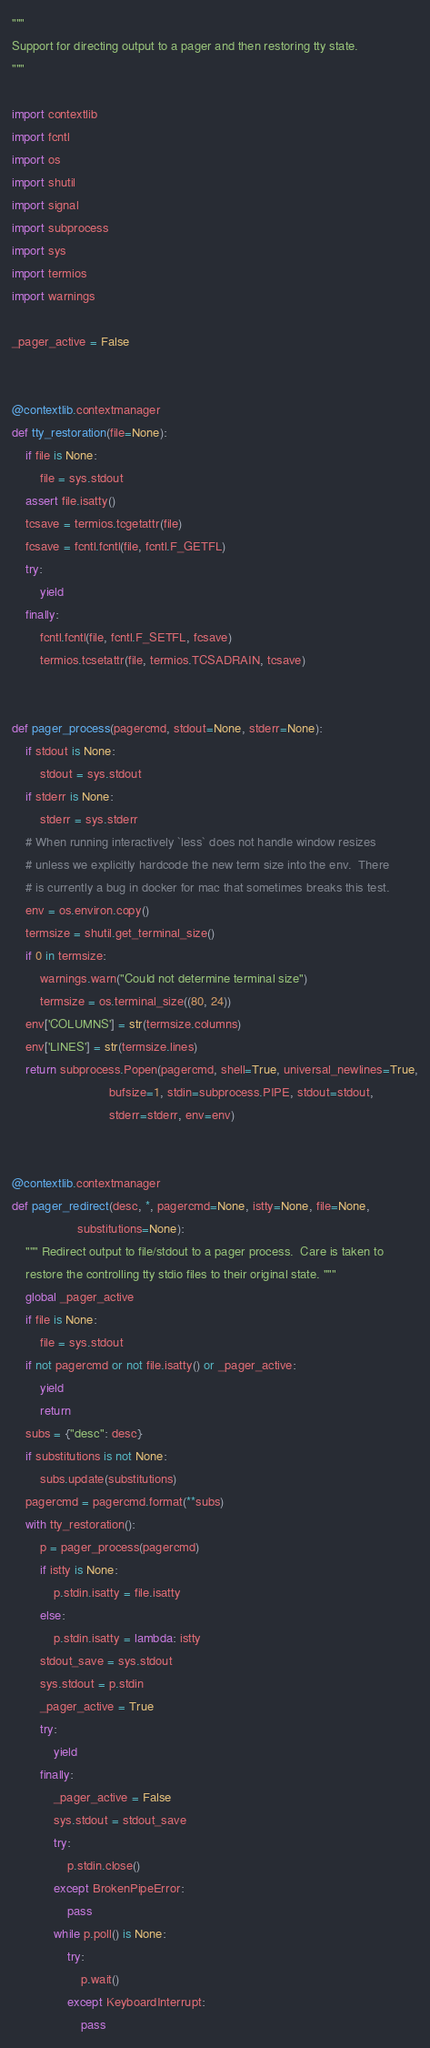<code> <loc_0><loc_0><loc_500><loc_500><_Python_>"""
Support for directing output to a pager and then restoring tty state.
"""

import contextlib
import fcntl
import os
import shutil
import signal
import subprocess
import sys
import termios
import warnings

_pager_active = False


@contextlib.contextmanager
def tty_restoration(file=None):
    if file is None:
        file = sys.stdout
    assert file.isatty()
    tcsave = termios.tcgetattr(file)
    fcsave = fcntl.fcntl(file, fcntl.F_GETFL)
    try:
        yield
    finally:
        fcntl.fcntl(file, fcntl.F_SETFL, fcsave)
        termios.tcsetattr(file, termios.TCSADRAIN, tcsave)


def pager_process(pagercmd, stdout=None, stderr=None):
    if stdout is None:
        stdout = sys.stdout
    if stderr is None:
        stderr = sys.stderr
    # When running interactively `less` does not handle window resizes
    # unless we explicitly hardcode the new term size into the env.  There
    # is currently a bug in docker for mac that sometimes breaks this test.
    env = os.environ.copy()
    termsize = shutil.get_terminal_size()
    if 0 in termsize:
        warnings.warn("Could not determine terminal size")
        termsize = os.terminal_size((80, 24))
    env['COLUMNS'] = str(termsize.columns)
    env['LINES'] = str(termsize.lines)
    return subprocess.Popen(pagercmd, shell=True, universal_newlines=True,
                            bufsize=1, stdin=subprocess.PIPE, stdout=stdout,
                            stderr=stderr, env=env)


@contextlib.contextmanager
def pager_redirect(desc, *, pagercmd=None, istty=None, file=None,
                   substitutions=None):
    """ Redirect output to file/stdout to a pager process.  Care is taken to
    restore the controlling tty stdio files to their original state. """
    global _pager_active
    if file is None:
        file = sys.stdout
    if not pagercmd or not file.isatty() or _pager_active:
        yield
        return
    subs = {"desc": desc}
    if substitutions is not None:
        subs.update(substitutions)
    pagercmd = pagercmd.format(**subs)
    with tty_restoration():
        p = pager_process(pagercmd)
        if istty is None:
            p.stdin.isatty = file.isatty
        else:
            p.stdin.isatty = lambda: istty
        stdout_save = sys.stdout
        sys.stdout = p.stdin
        _pager_active = True
        try:
            yield
        finally:
            _pager_active = False
            sys.stdout = stdout_save
            try:
                p.stdin.close()
            except BrokenPipeError:
                pass
            while p.poll() is None:
                try:
                    p.wait()
                except KeyboardInterrupt:
                    pass
</code> 